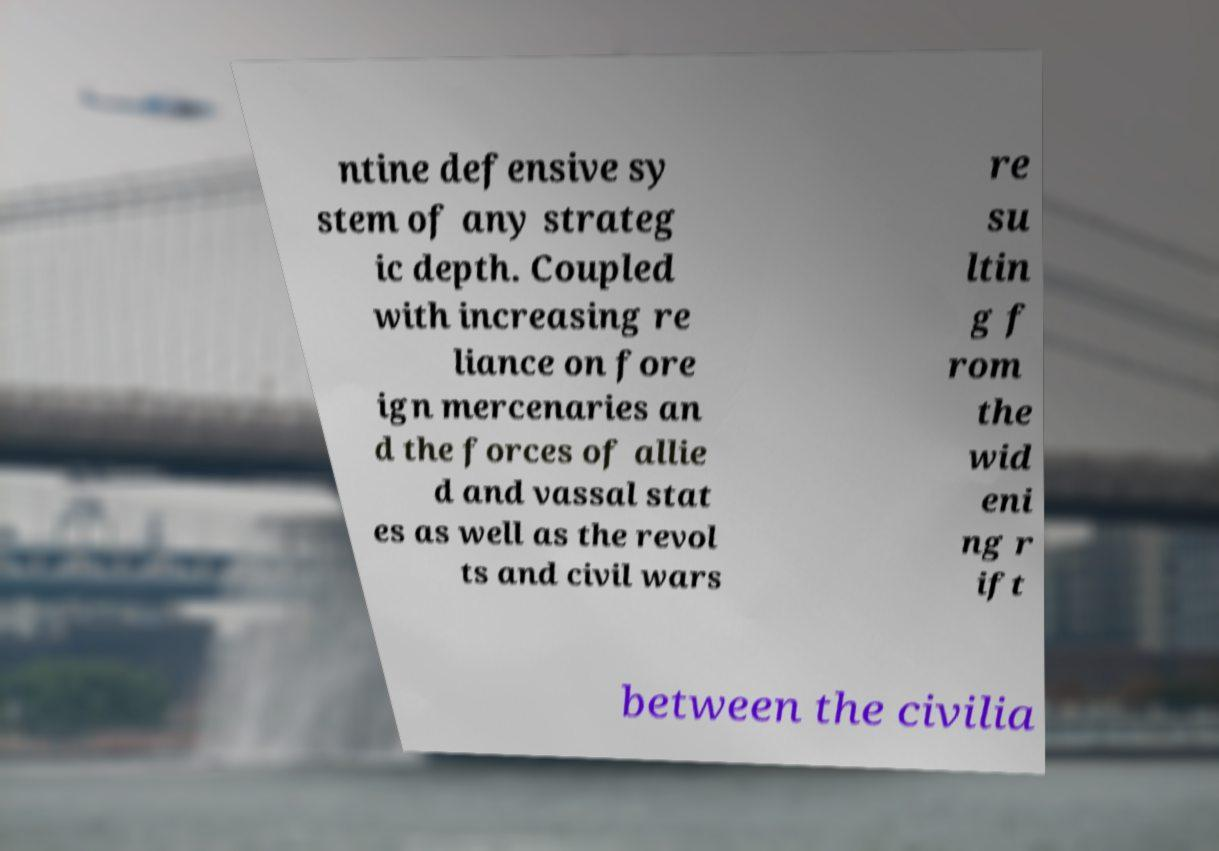What messages or text are displayed in this image? I need them in a readable, typed format. ntine defensive sy stem of any strateg ic depth. Coupled with increasing re liance on fore ign mercenaries an d the forces of allie d and vassal stat es as well as the revol ts and civil wars re su ltin g f rom the wid eni ng r ift between the civilia 